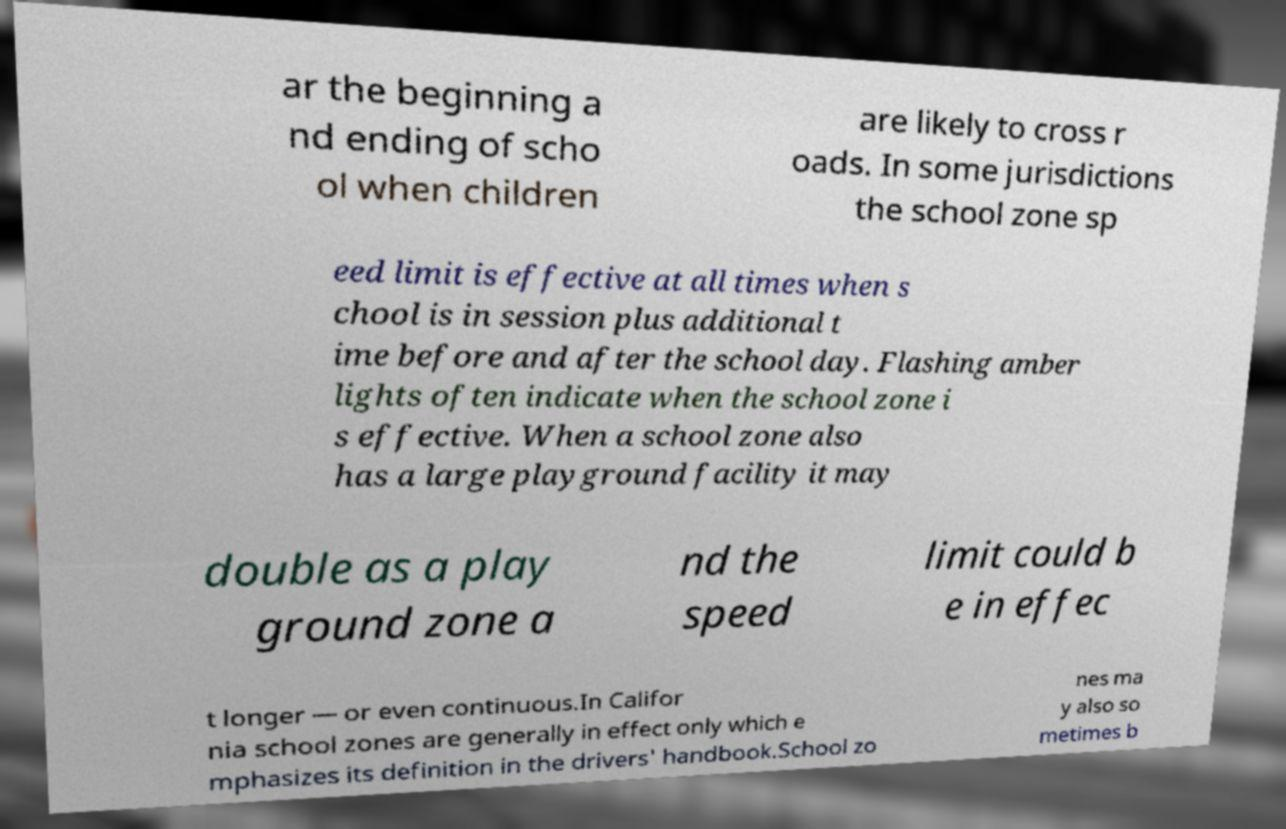I need the written content from this picture converted into text. Can you do that? ar the beginning a nd ending of scho ol when children are likely to cross r oads. In some jurisdictions the school zone sp eed limit is effective at all times when s chool is in session plus additional t ime before and after the school day. Flashing amber lights often indicate when the school zone i s effective. When a school zone also has a large playground facility it may double as a play ground zone a nd the speed limit could b e in effec t longer — or even continuous.In Califor nia school zones are generally in effect only which e mphasizes its definition in the drivers' handbook.School zo nes ma y also so metimes b 